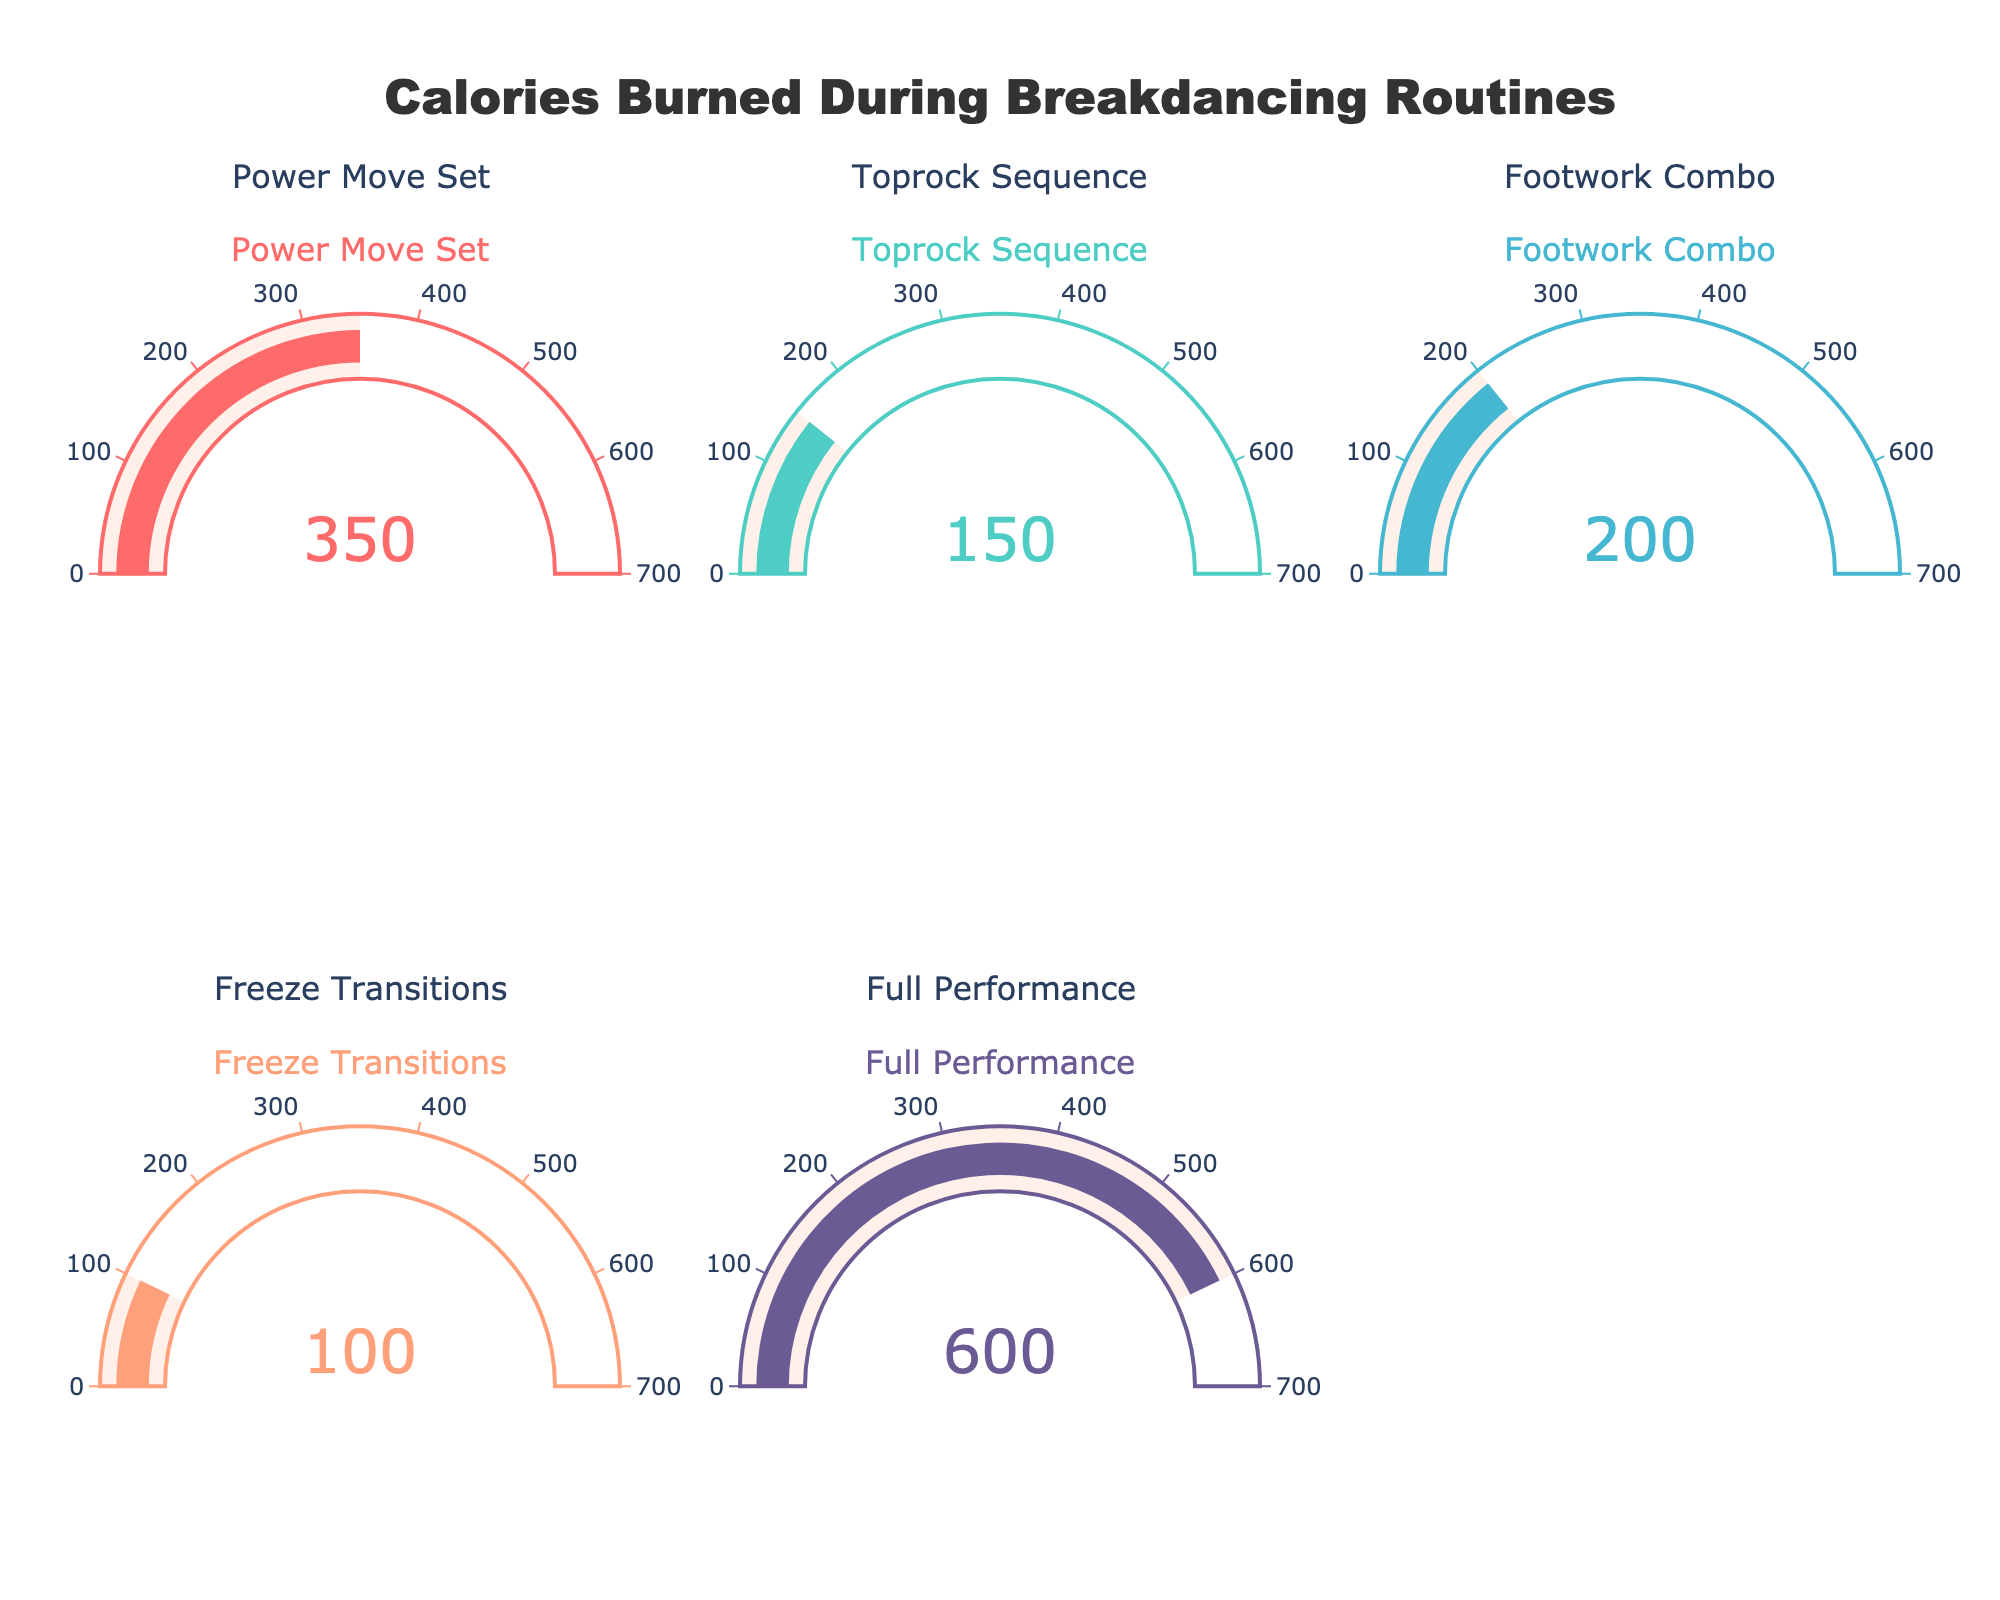How many routines are displayed in the figure? Count the number of gauge charts displayed. There are 5 different gauge charts, each representing a different routine.
Answer: 5 Which routine burns the most calories? Compare the value of each gauge chart. The routine with the highest value is "Full Performance" with 600 calories burned.
Answer: Full Performance Which routine burns the least amount of calories? Find the gauge chart with the smallest value. "Freeze Transitions" has the smallest value with 100 calories burned.
Answer: Freeze Transitions What is the combined total of calories burned for "Power Move Set" and "Toprock Sequence"? Add the calories burned for "Power Move Set" (350) and "Toprock Sequence" (150). The sum is 350 + 150 = 500 calories.
Answer: 500 What's the difference in calories burned between "Footwork Combo" and "Freeze Transitions"? Subtract the calories burned for "Freeze Transitions" (100) from the calories burned for "Footwork Combo" (200). The difference is 200 - 100 = 100 calories.
Answer: 100 On average, how many calories are burned per routine? Sum all the calories burned and divide by the number of routines. (350 + 150 + 200 + 100 + 600) / 5 = 1400 / 5 = 280 calories per routine.
Answer: 280 How many routines burn more than 200 calories per session? Identify and count the routines with calories burned greater than 200: "Power Move Set" (350), "Full Performance" (600). This results in 2 routines.
Answer: 2 Are there more routines burning fewer than 200 calories or more than 200 calories? Compare the number of routines burning fewer than 200 calories: "Toprock Sequence" (150), "Freeze Transitions" (100) - 2 routines; versus routines burning more than 200 calories: "Power Move Set" (350), "Footwork Combo" (200), "Full Performance" (600) - 3 routines. There are more routines burning more than 200 calories.
Answer: More than 200 calories 